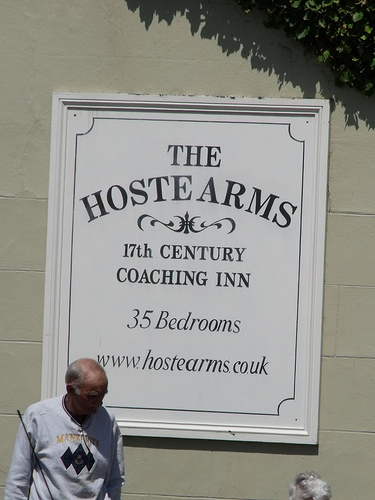<image>
Is the man in front of the sign? Yes. The man is positioned in front of the sign, appearing closer to the camera viewpoint. 